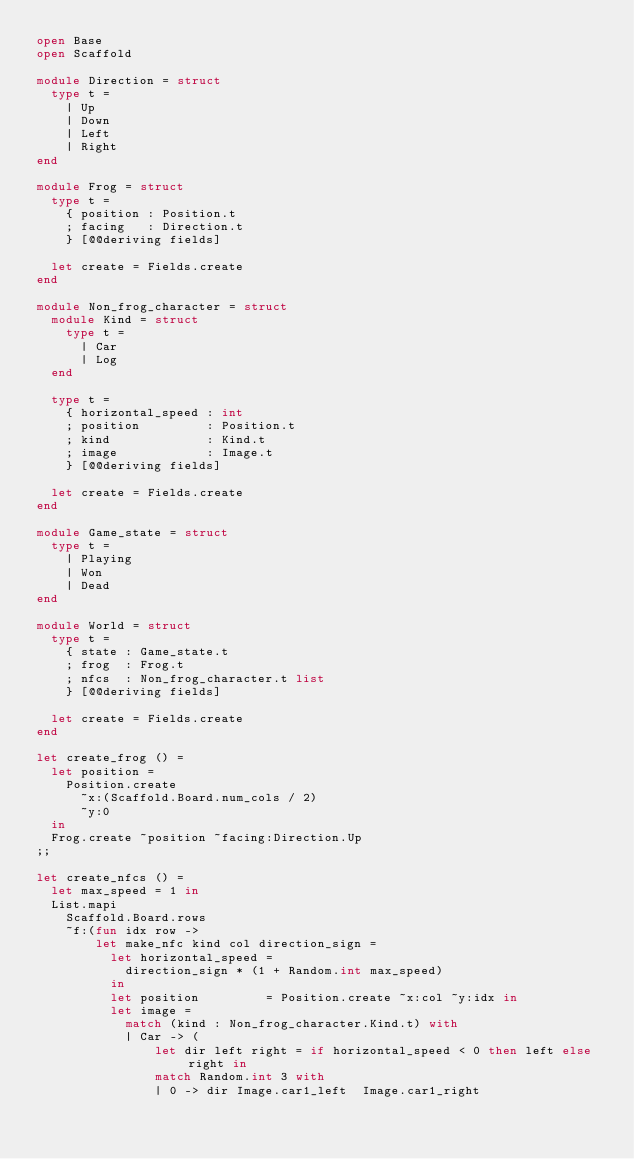<code> <loc_0><loc_0><loc_500><loc_500><_OCaml_>open Base
open Scaffold

module Direction = struct
  type t =
    | Up 
    | Down
    | Left
    | Right
end

module Frog = struct
  type t =
    { position : Position.t
    ; facing   : Direction.t
    } [@@deriving fields]

  let create = Fields.create
end

module Non_frog_character = struct
  module Kind = struct
    type t =
      | Car
      | Log
  end

  type t =
    { horizontal_speed : int
    ; position         : Position.t
    ; kind             : Kind.t
    ; image            : Image.t
    } [@@deriving fields]

  let create = Fields.create
end

module Game_state = struct
  type t =
    | Playing
    | Won
    | Dead
end

module World = struct
  type t =
    { state : Game_state.t
    ; frog  : Frog.t
    ; nfcs  : Non_frog_character.t list
    } [@@deriving fields]

  let create = Fields.create
end

let create_frog () =
  let position =
    Position.create
      ~x:(Scaffold.Board.num_cols / 2)
      ~y:0
  in
  Frog.create ~position ~facing:Direction.Up
;;

let create_nfcs () =
  let max_speed = 1 in
  List.mapi
    Scaffold.Board.rows
    ~f:(fun idx row ->
        let make_nfc kind col direction_sign =
          let horizontal_speed =
            direction_sign * (1 + Random.int max_speed)
          in
          let position         = Position.create ~x:col ~y:idx in
          let image =
            match (kind : Non_frog_character.Kind.t) with
            | Car -> (
                let dir left right = if horizontal_speed < 0 then left else right in
                match Random.int 3 with
                | 0 -> dir Image.car1_left  Image.car1_right</code> 